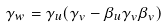<formula> <loc_0><loc_0><loc_500><loc_500>\gamma _ { w } = \gamma _ { u } ( \gamma _ { v } - \beta _ { u } \gamma _ { v } \beta _ { v } )</formula> 